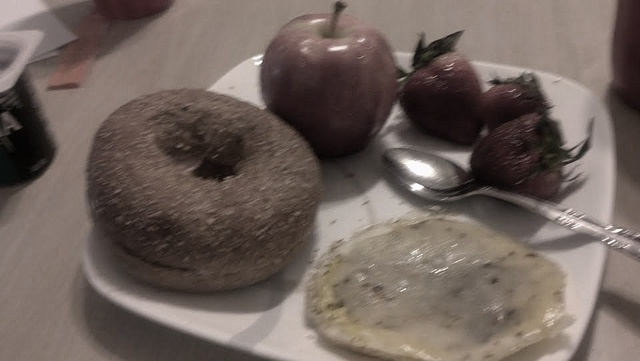Describe the objects in this image and their specific colors. I can see dining table in darkgray and gray tones, donut in darkgray, gray, and black tones, apple in darkgray, black, and gray tones, spoon in darkgray, gray, black, and white tones, and cup in darkgray, black, and gray tones in this image. 